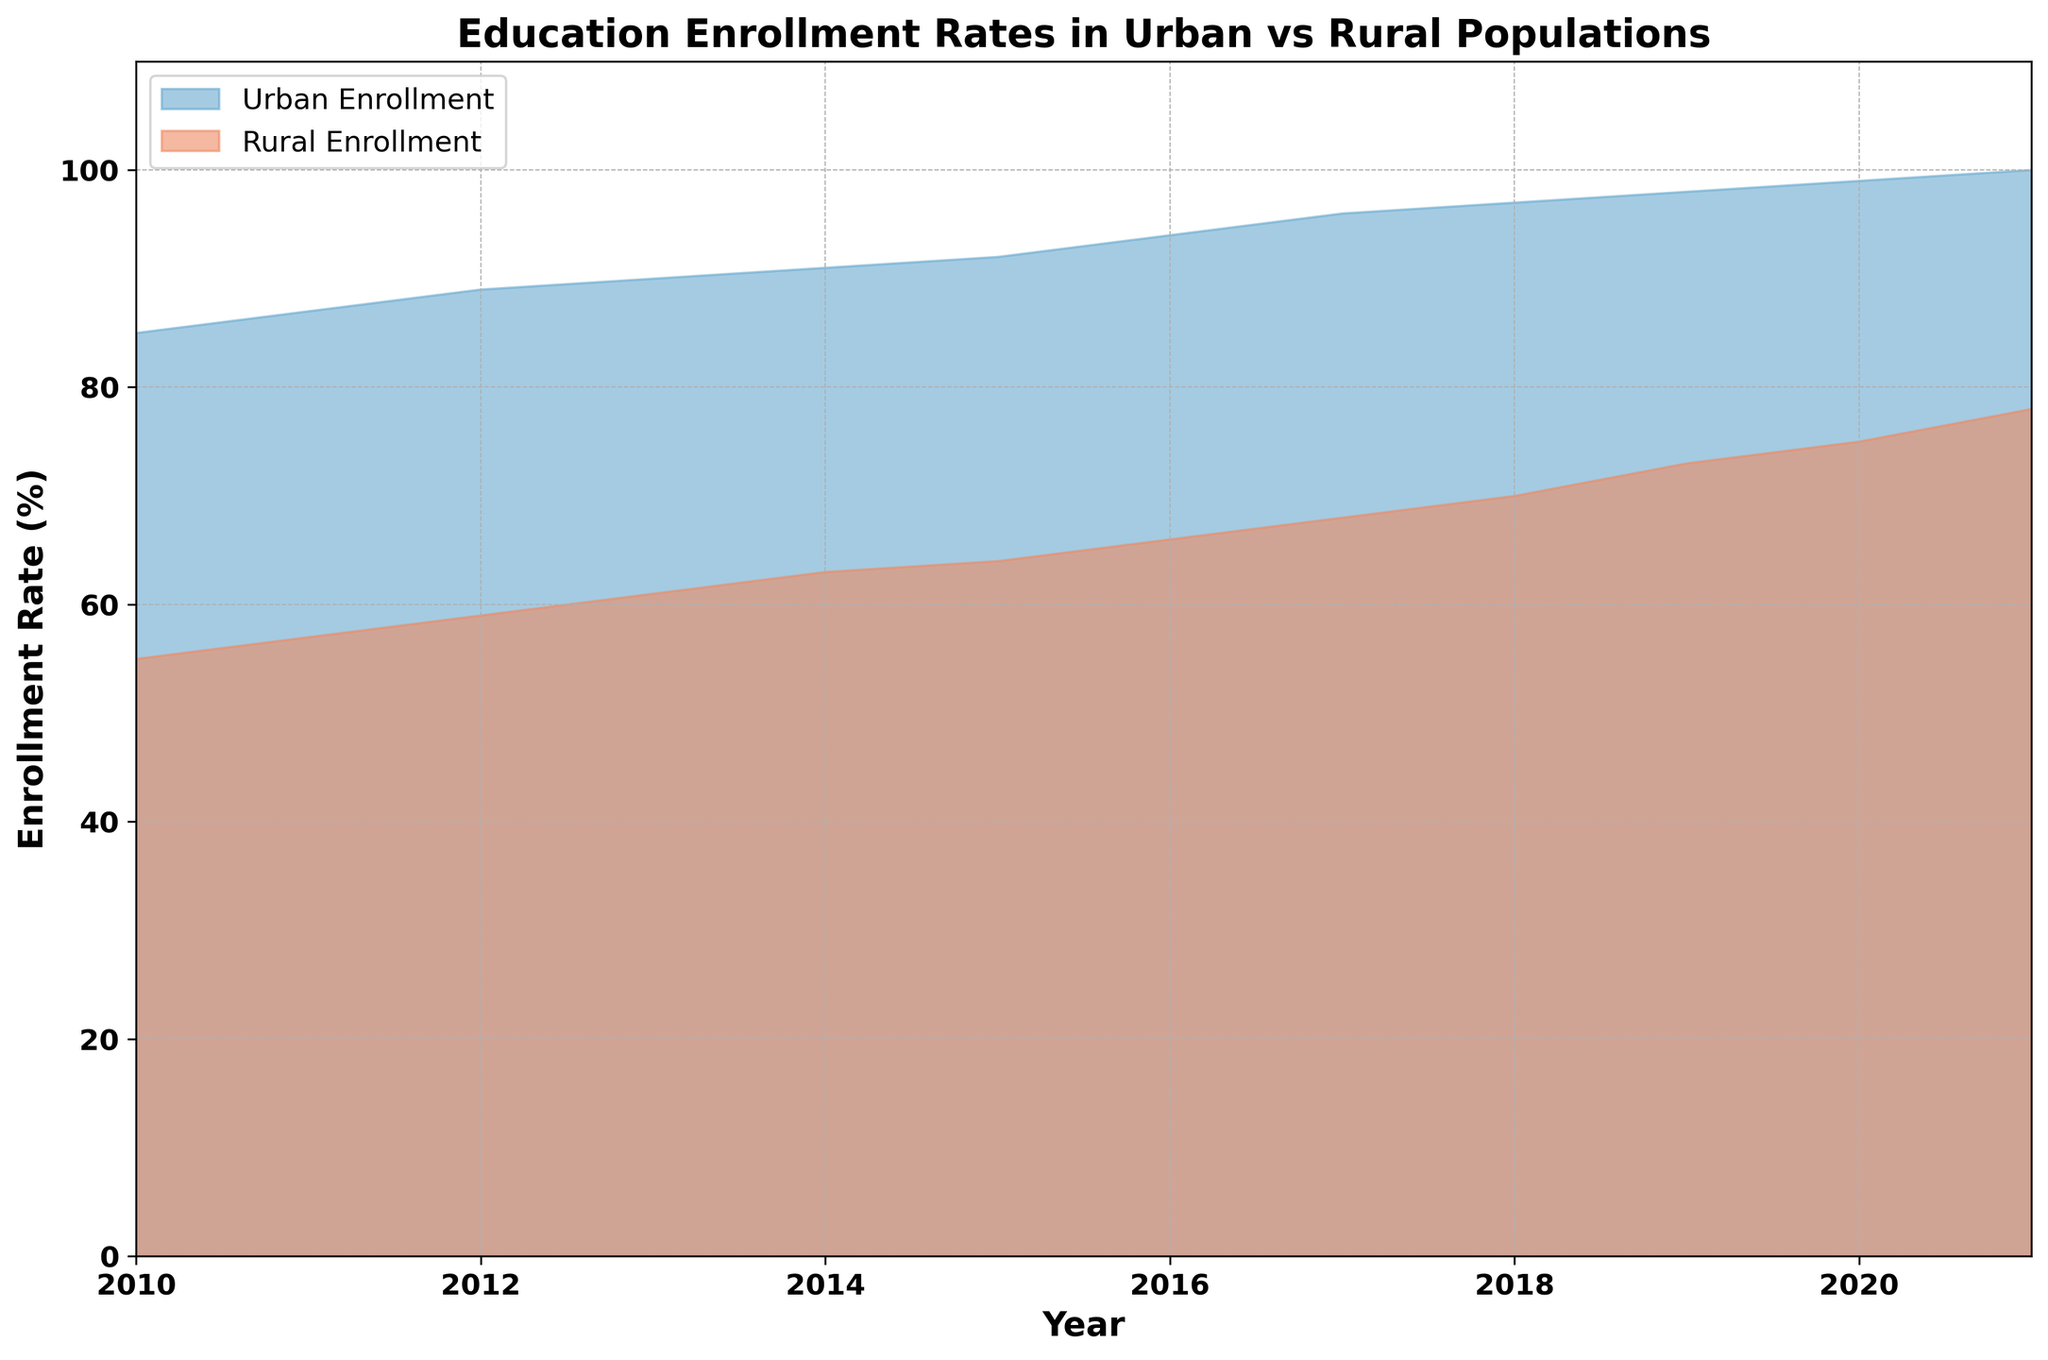What's the difference in urban and rural enrollment rates in 2013? First, identify the enrollment rate for urban and rural populations in 2013 from the chart. Urban Enrollment in 2013 is 90%, while Rural Enrollment in 2013 is 61%. Subtract the two values: 90% - 61% = 29%.
Answer: 29% In which year does the rural area reach an enrollment rate of 70%? Locate the point where the rural enrollment rate hits 70% on the graph, which occurs in 2018.
Answer: 2018 By how many percentage points did urban enrollment increase from 2010 to 2021? Identify the urban enrollment rate in 2010 (85%) and in 2021 (100%). Subtract the 2010 value from the 2021 value: 100% - 85% = 15%.
Answer: 15% In which year do urban and rural enrollment rates differ by the smallest margin? Examine each year and subtract the rural enrollment rate from the urban enrollment rate to find the smallest difference. Noticeably, in 2021, the difference is smallest: Urban (100%) - Rural (78%) = 22%.
Answer: 2021 Which year had the highest rate of increase in rural enrollment compared to the previous year? Calculate the increase in rural enrollment each year by subtracting the previous year's rate. The highest increase occurred from 2020 to 2021: 2021 (78%) - 2020 (75%) = 3 percentage points.
Answer: 2021 What is the average urban enrollment rate over the given years? Add the enrollment rates for urban areas from 2010 to 2021 and divide by the number of years. (85 + 87 + 89 + 90 + 91 + 92 + 94 + 96 + 97 + 98 + 99 + 100) / 12 = 91.75%.
Answer: 91.75% How does the overall trend of urban enrollment compare to that of rural enrollment from 2010 to 2021? Observe the trends in the chart for both urban and rural enrollments. Urban enrollment shows a steady increase, whereas rural enrollment also increases but at a generally slower rate. This comparison reveals both upward trends, with urban enrollment starting higher and increasing more rapidly.
Answer: Both increase, urban more rapidly What is the visual difference between the representation of urban and rural enrollment rates on the chart? The urban enrollment rate is shown with a blue area, while the rural enrollment rate is shown with a red area. Both use different colors to represent their respective enrollment trends clearly.
Answer: Blue for urban, red for rural In which year does urban enrollment hit the maximum possible value in the data set? Identify the highest point on the chart for urban enrollment, which is 100% in 2021.
Answer: 2021 